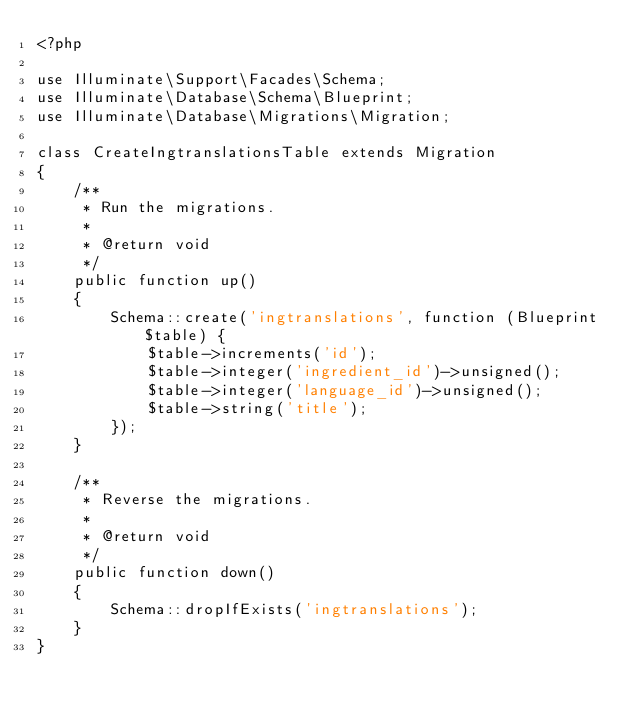Convert code to text. <code><loc_0><loc_0><loc_500><loc_500><_PHP_><?php

use Illuminate\Support\Facades\Schema;
use Illuminate\Database\Schema\Blueprint;
use Illuminate\Database\Migrations\Migration;

class CreateIngtranslationsTable extends Migration
{
    /**
     * Run the migrations.
     *
     * @return void
     */
    public function up()
    {
        Schema::create('ingtranslations', function (Blueprint $table) {
            $table->increments('id');
            $table->integer('ingredient_id')->unsigned();
            $table->integer('language_id')->unsigned();
            $table->string('title');
        });
    }

    /**
     * Reverse the migrations.
     *
     * @return void
     */
    public function down()
    {
        Schema::dropIfExists('ingtranslations');
    }
}
</code> 